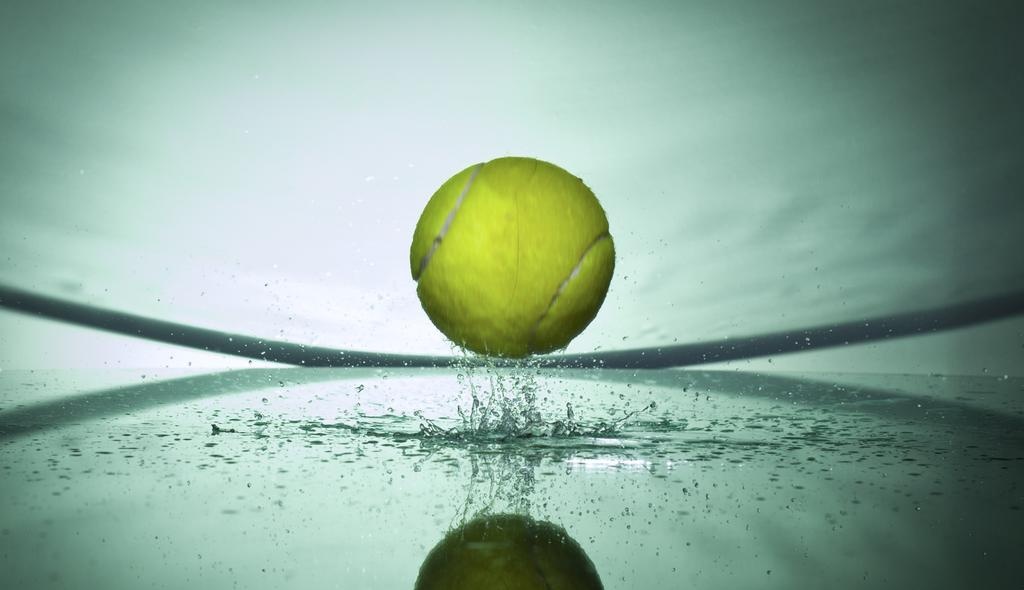What is the color of the ball in the image? The ball in the image is yellow. What is the primary element visible in the image? There is water visible in the image. What is the color of the background in the image? The background of the image is white. What type of drum can be seen floating in the water in the image? There is no drum present in the image; it only features a yellow ball and water. What type of cracker is visible on the white background in the image? There is no cracker present in the image; it only features a yellow ball and water against a white background. 